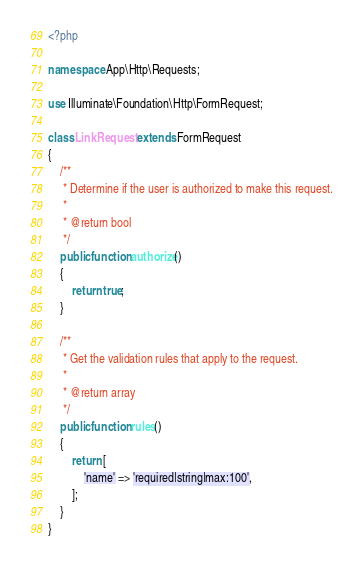Convert code to text. <code><loc_0><loc_0><loc_500><loc_500><_PHP_><?php

namespace App\Http\Requests;

use Illuminate\Foundation\Http\FormRequest;

class LinkRequest extends FormRequest
{
    /**
     * Determine if the user is authorized to make this request.
     *
     * @return bool
     */
    public function authorize()
    {
        return true;
    }

    /**
     * Get the validation rules that apply to the request.
     *
     * @return array
     */
    public function rules()
    {
        return [
            'name' => 'required|string|max:100',
        ];
    }
}
</code> 